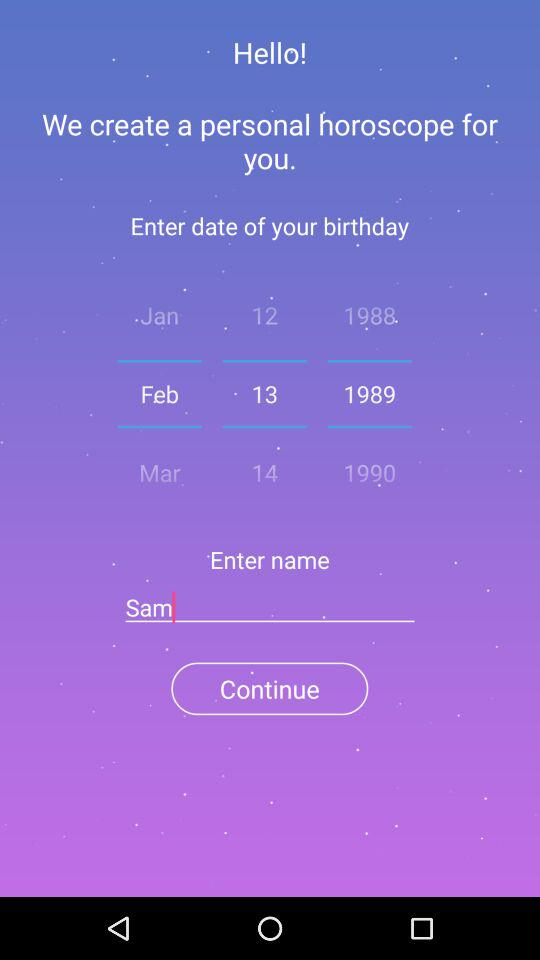Which day of the week falls on February 13, 1989?
When the provided information is insufficient, respond with <no answer>. <no answer> 